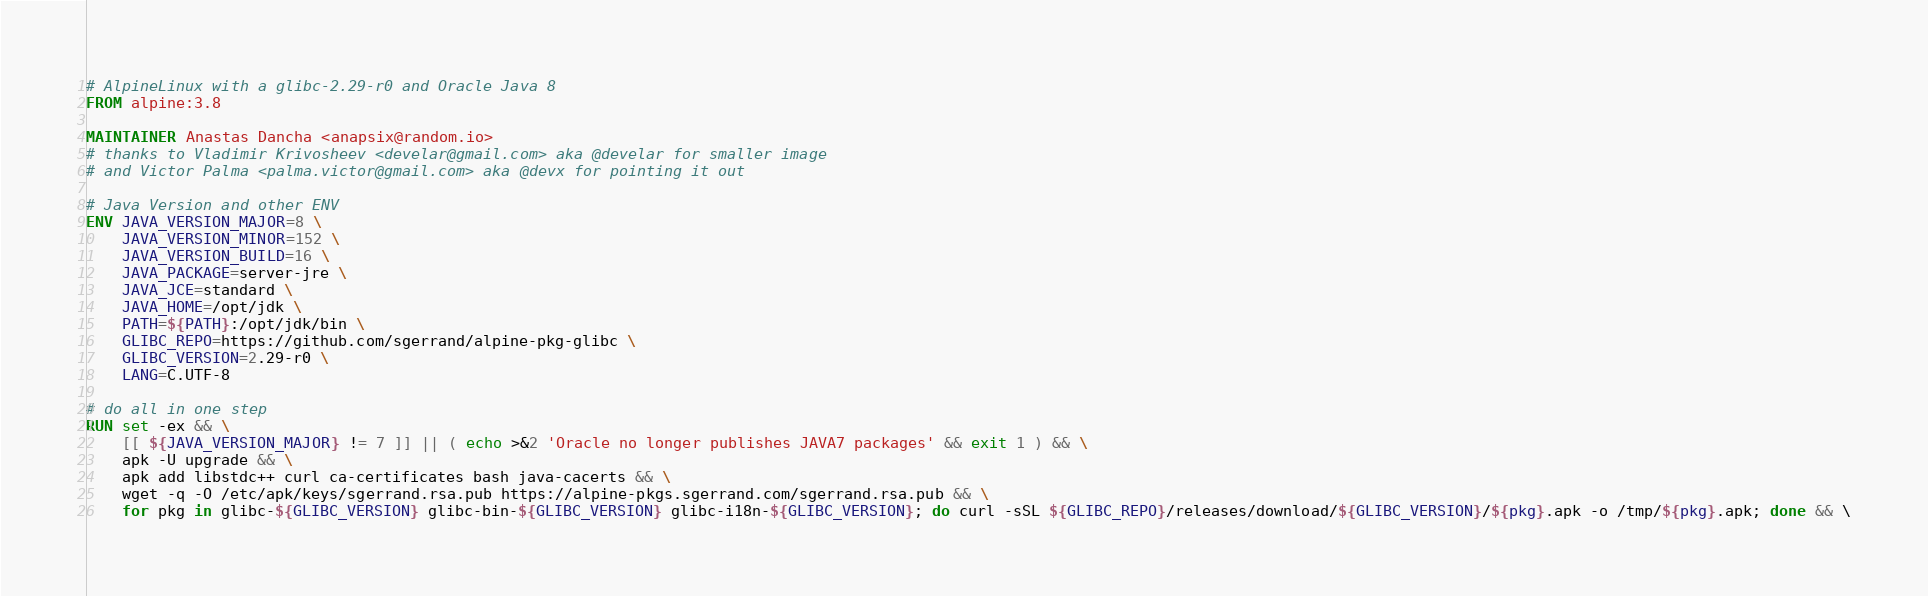<code> <loc_0><loc_0><loc_500><loc_500><_Dockerfile_># AlpineLinux with a glibc-2.29-r0 and Oracle Java 8
FROM alpine:3.8

MAINTAINER Anastas Dancha <anapsix@random.io>
# thanks to Vladimir Krivosheev <develar@gmail.com> aka @develar for smaller image
# and Victor Palma <palma.victor@gmail.com> aka @devx for pointing it out

# Java Version and other ENV
ENV JAVA_VERSION_MAJOR=8 \
    JAVA_VERSION_MINOR=152 \
    JAVA_VERSION_BUILD=16 \
    JAVA_PACKAGE=server-jre \
    JAVA_JCE=standard \
    JAVA_HOME=/opt/jdk \
    PATH=${PATH}:/opt/jdk/bin \
    GLIBC_REPO=https://github.com/sgerrand/alpine-pkg-glibc \
    GLIBC_VERSION=2.29-r0 \
    LANG=C.UTF-8

# do all in one step
RUN set -ex && \
    [[ ${JAVA_VERSION_MAJOR} != 7 ]] || ( echo >&2 'Oracle no longer publishes JAVA7 packages' && exit 1 ) && \
    apk -U upgrade && \
    apk add libstdc++ curl ca-certificates bash java-cacerts && \
    wget -q -O /etc/apk/keys/sgerrand.rsa.pub https://alpine-pkgs.sgerrand.com/sgerrand.rsa.pub && \
    for pkg in glibc-${GLIBC_VERSION} glibc-bin-${GLIBC_VERSION} glibc-i18n-${GLIBC_VERSION}; do curl -sSL ${GLIBC_REPO}/releases/download/${GLIBC_VERSION}/${pkg}.apk -o /tmp/${pkg}.apk; done && \</code> 